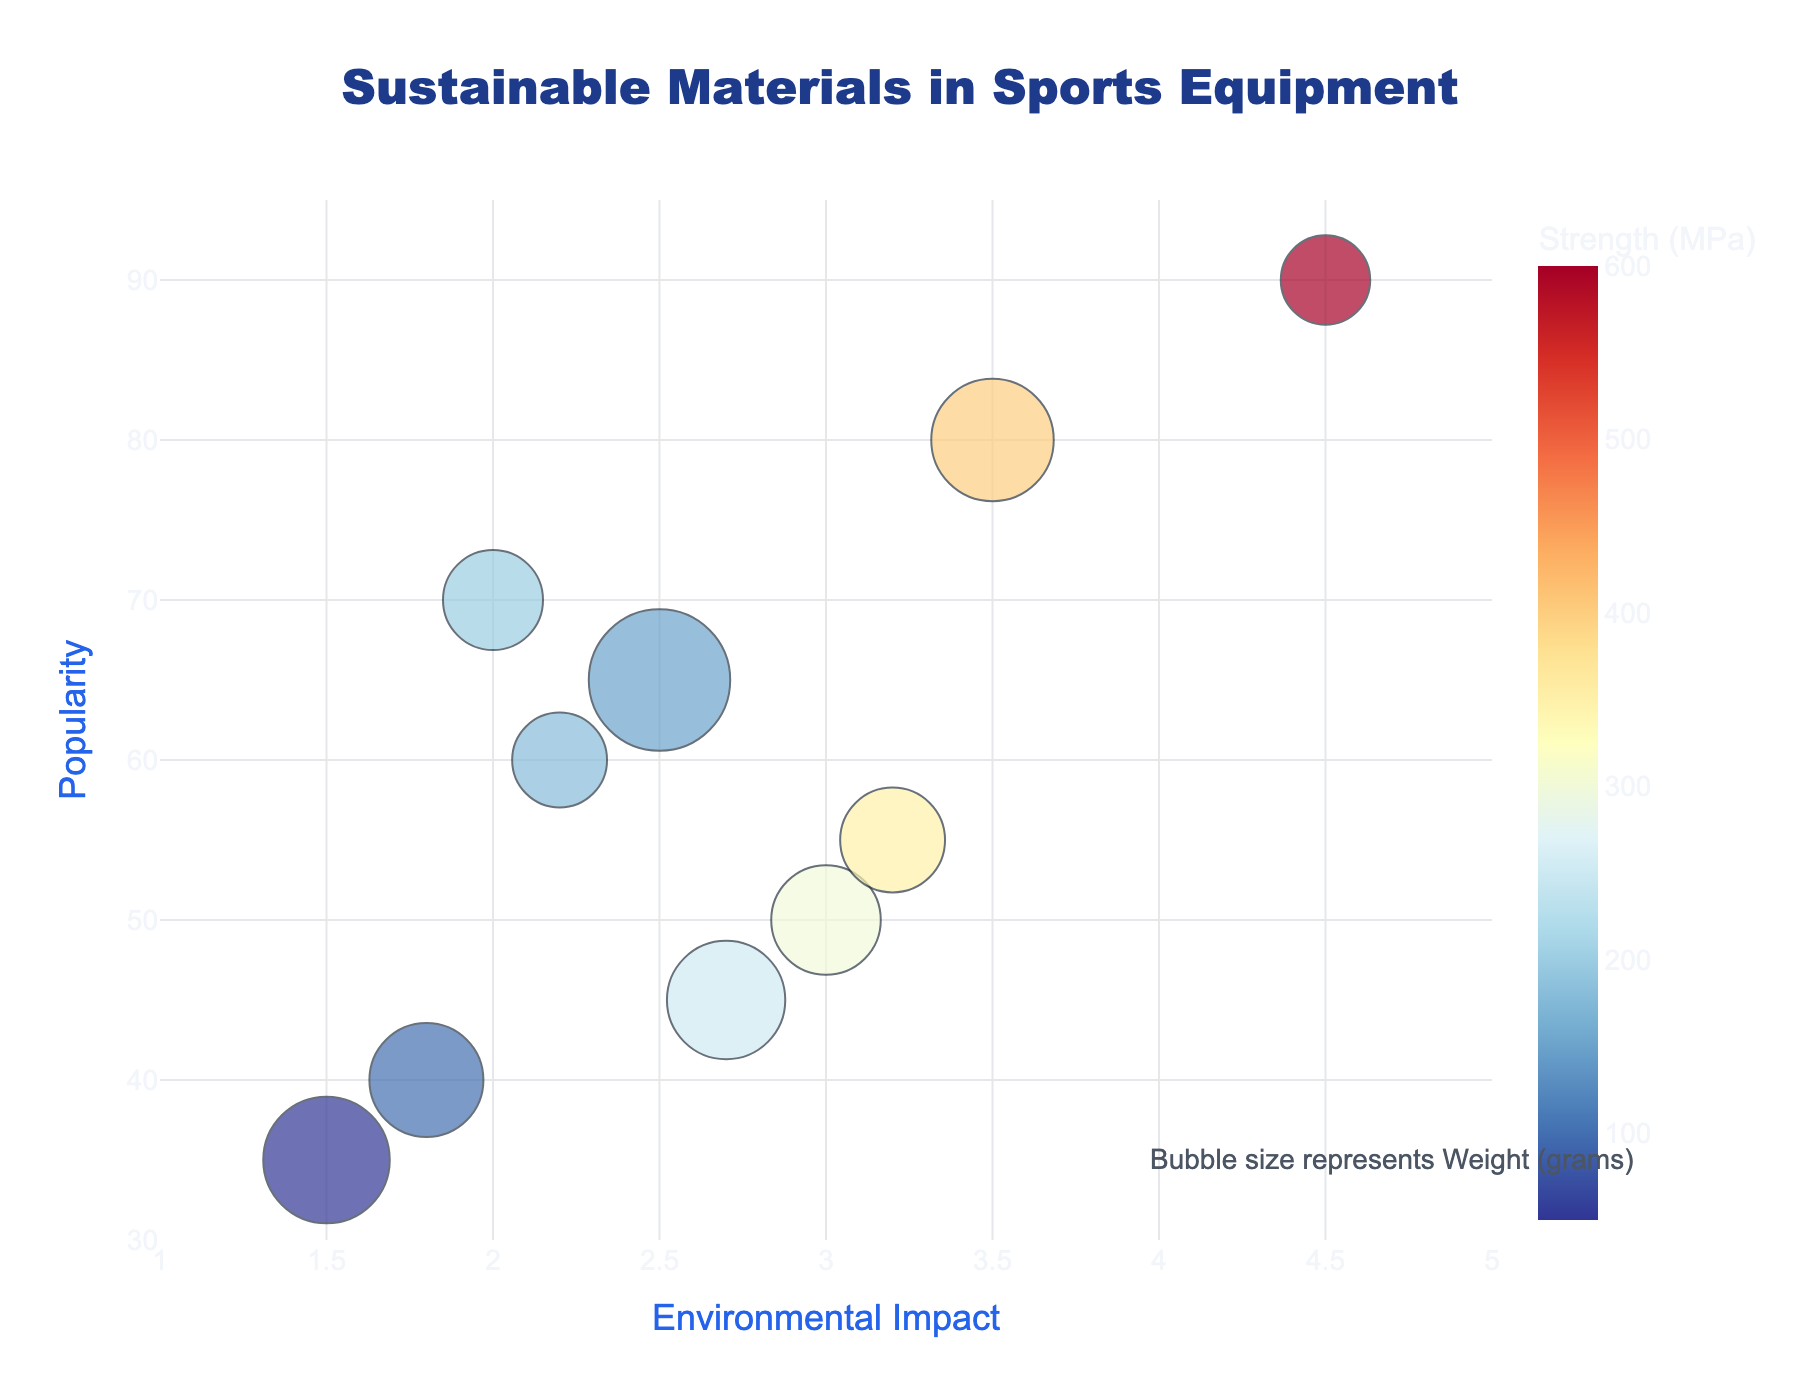What is the title of the figure? The title is usually displayed at the top of the chart.
Answer: Sustainable Materials in Sports Equipment What does the x-axis represent? The x-axis label is given directly below the horizontal axis.
Answer: Environmental Impact Which material has the highest popularity? The y-axis represents popularity, so the material at the highest point on the y-axis is the answer.
Answer: Carbon Fiber How many materials have an environmental impact score greater than 3.0? Look for points on the chart that are to the right of the 3.0 mark on the x-axis and count them.
Answer: Five materials Which material is the heaviest? The bubble size represents weight, so the largest bubble on the chart indicates the heaviest material.
Answer: Recycled Rubber Which material has the highest strength? The color scale represents strength, so the material with the most intense color corresponding to the maximum value on the color scale has the highest strength.
Answer: Carbon Fiber Is there a material that has both low environmental impact and high popularity? Check for bubbles located towards the bottom left of the chart, as these regions represent low impact and high popularity.
Answer: Bamboo Fiber (Impact 2.0, Popularity 70) What is the range of popularity for materials with an environmental impact less than 2.5? Identify materials with environmental impacts below 2.5, then check their positions on the y-axis to determine the range of their popularity values.
Answer: 35 to 70 Which material is both lightest and has high strength? Smaller bubbles represent lighter materials, and the more intense colors indicate higher strength. Look for the smallest, most intensely colored bubble.
Answer: Carbon Fiber How does the popularity of Recycled PET compare to Basalt Fiber? Locate Recycled PET and Basalt Fiber on the chart and compare their positions along the y-axis.
Answer: Recycled PET is more popular (Popularity 50 vs. Basalt Fiber's 55) 